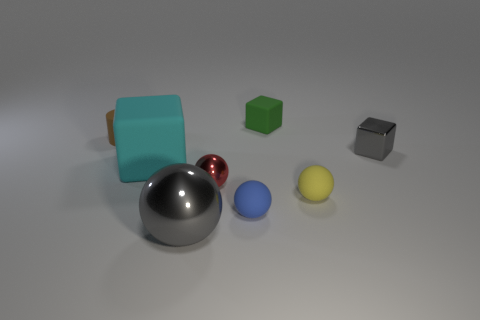What is the color of the cylinder that is the same material as the green object? The cylinder that shares the same material appearance as the green cube is brown, exhibiting a reflective surface similar to the green cube's matte finish. 